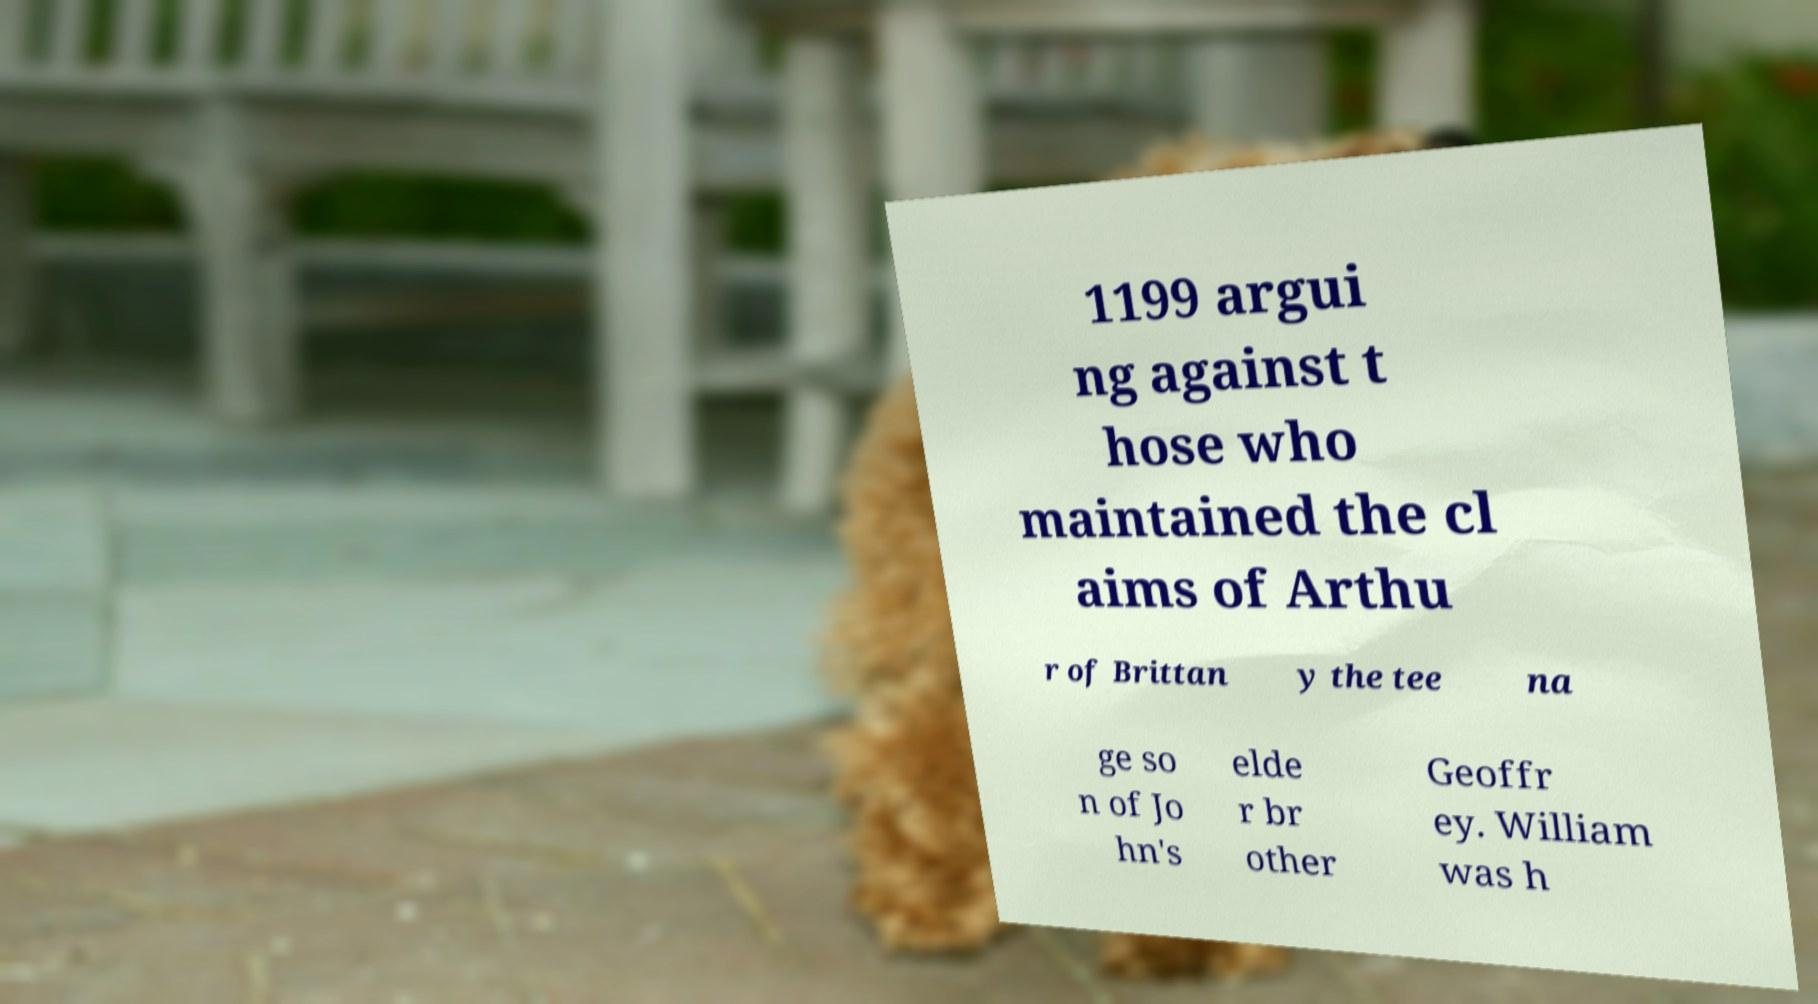Please read and relay the text visible in this image. What does it say? 1199 argui ng against t hose who maintained the cl aims of Arthu r of Brittan y the tee na ge so n of Jo hn's elde r br other Geoffr ey. William was h 